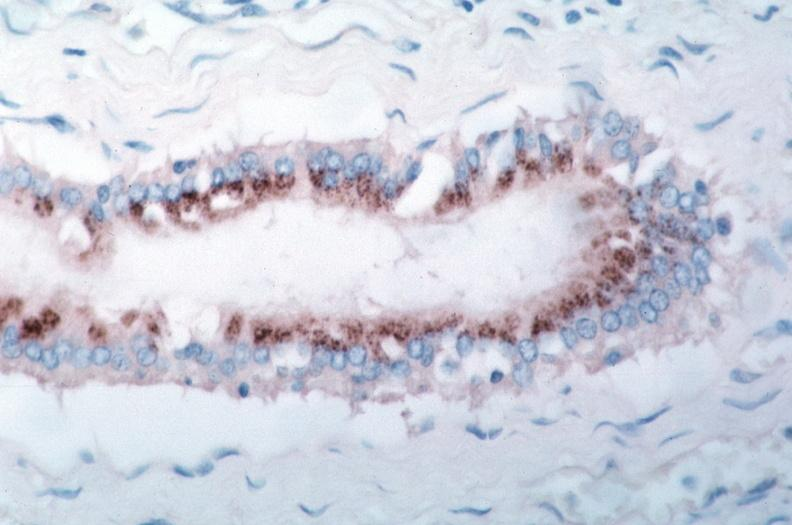s vasculature present?
Answer the question using a single word or phrase. Yes 